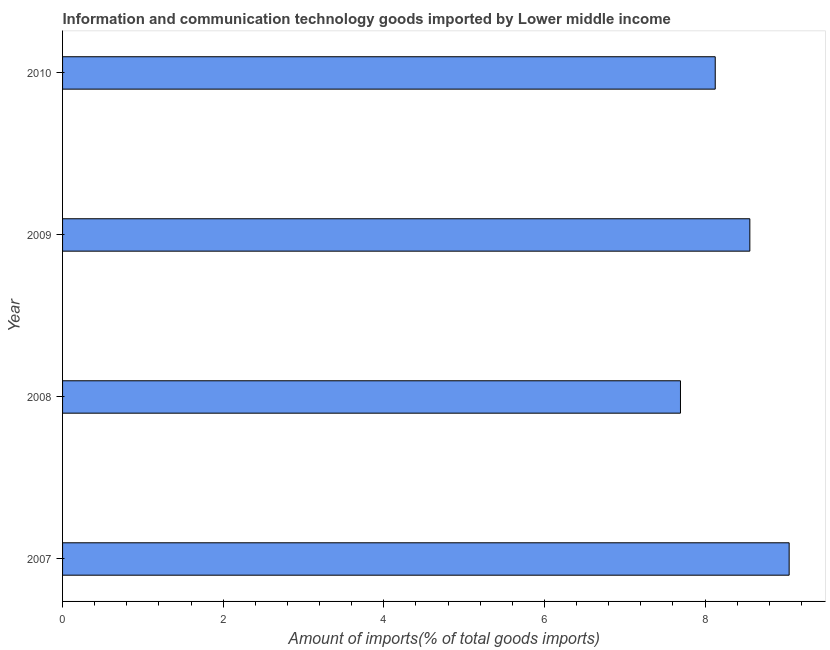Does the graph contain any zero values?
Your answer should be very brief. No. Does the graph contain grids?
Make the answer very short. No. What is the title of the graph?
Make the answer very short. Information and communication technology goods imported by Lower middle income. What is the label or title of the X-axis?
Offer a terse response. Amount of imports(% of total goods imports). What is the amount of ict goods imports in 2010?
Offer a very short reply. 8.13. Across all years, what is the maximum amount of ict goods imports?
Ensure brevity in your answer.  9.05. Across all years, what is the minimum amount of ict goods imports?
Your response must be concise. 7.69. In which year was the amount of ict goods imports maximum?
Offer a terse response. 2007. In which year was the amount of ict goods imports minimum?
Make the answer very short. 2008. What is the sum of the amount of ict goods imports?
Provide a short and direct response. 33.42. What is the difference between the amount of ict goods imports in 2008 and 2010?
Your response must be concise. -0.43. What is the average amount of ict goods imports per year?
Keep it short and to the point. 8.36. What is the median amount of ict goods imports?
Your answer should be very brief. 8.34. In how many years, is the amount of ict goods imports greater than 1.2 %?
Keep it short and to the point. 4. What is the ratio of the amount of ict goods imports in 2007 to that in 2009?
Offer a terse response. 1.06. Is the amount of ict goods imports in 2007 less than that in 2010?
Your answer should be compact. No. Is the difference between the amount of ict goods imports in 2007 and 2009 greater than the difference between any two years?
Keep it short and to the point. No. What is the difference between the highest and the second highest amount of ict goods imports?
Offer a very short reply. 0.49. Is the sum of the amount of ict goods imports in 2007 and 2010 greater than the maximum amount of ict goods imports across all years?
Your answer should be compact. Yes. What is the difference between the highest and the lowest amount of ict goods imports?
Give a very brief answer. 1.35. In how many years, is the amount of ict goods imports greater than the average amount of ict goods imports taken over all years?
Provide a short and direct response. 2. How many bars are there?
Your answer should be very brief. 4. Are all the bars in the graph horizontal?
Offer a terse response. Yes. How many years are there in the graph?
Give a very brief answer. 4. What is the difference between two consecutive major ticks on the X-axis?
Provide a short and direct response. 2. Are the values on the major ticks of X-axis written in scientific E-notation?
Your answer should be very brief. No. What is the Amount of imports(% of total goods imports) in 2007?
Ensure brevity in your answer.  9.05. What is the Amount of imports(% of total goods imports) in 2008?
Your answer should be very brief. 7.69. What is the Amount of imports(% of total goods imports) in 2009?
Ensure brevity in your answer.  8.56. What is the Amount of imports(% of total goods imports) in 2010?
Your answer should be very brief. 8.13. What is the difference between the Amount of imports(% of total goods imports) in 2007 and 2008?
Keep it short and to the point. 1.35. What is the difference between the Amount of imports(% of total goods imports) in 2007 and 2009?
Offer a terse response. 0.49. What is the difference between the Amount of imports(% of total goods imports) in 2007 and 2010?
Make the answer very short. 0.92. What is the difference between the Amount of imports(% of total goods imports) in 2008 and 2009?
Your answer should be very brief. -0.86. What is the difference between the Amount of imports(% of total goods imports) in 2008 and 2010?
Provide a succinct answer. -0.43. What is the difference between the Amount of imports(% of total goods imports) in 2009 and 2010?
Give a very brief answer. 0.43. What is the ratio of the Amount of imports(% of total goods imports) in 2007 to that in 2008?
Keep it short and to the point. 1.18. What is the ratio of the Amount of imports(% of total goods imports) in 2007 to that in 2009?
Offer a terse response. 1.06. What is the ratio of the Amount of imports(% of total goods imports) in 2007 to that in 2010?
Your response must be concise. 1.11. What is the ratio of the Amount of imports(% of total goods imports) in 2008 to that in 2009?
Your answer should be very brief. 0.9. What is the ratio of the Amount of imports(% of total goods imports) in 2008 to that in 2010?
Provide a short and direct response. 0.95. What is the ratio of the Amount of imports(% of total goods imports) in 2009 to that in 2010?
Offer a very short reply. 1.05. 